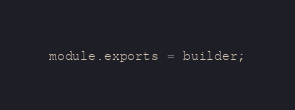Convert code to text. <code><loc_0><loc_0><loc_500><loc_500><_JavaScript_>
module.exports = builder;
</code> 